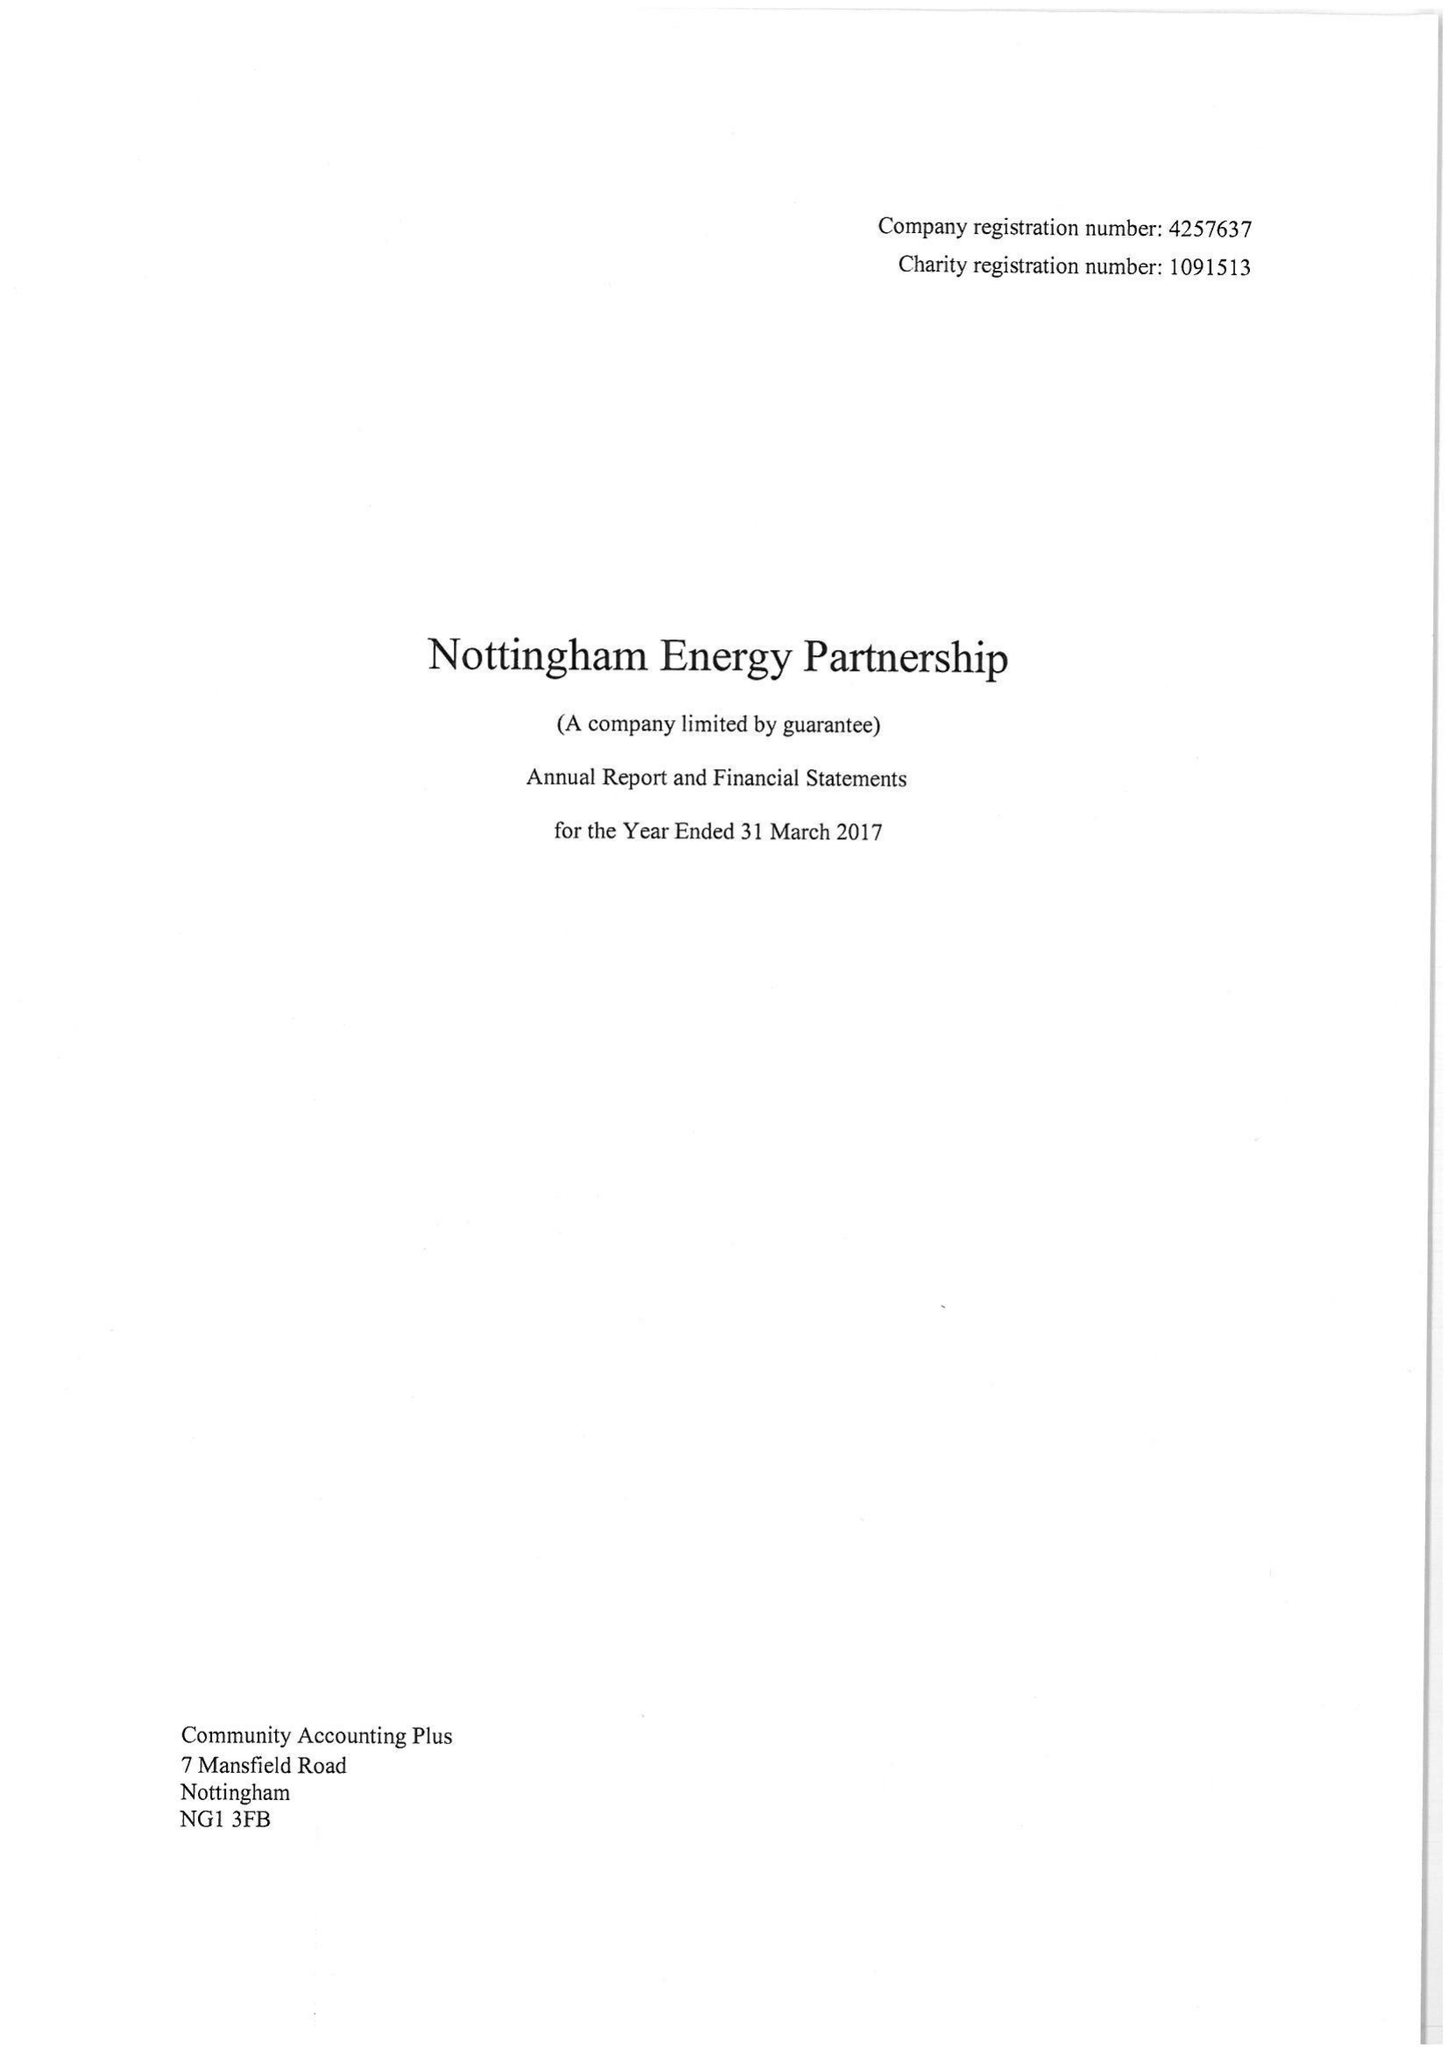What is the value for the address__postcode?
Answer the question using a single word or phrase. NG2 3DY 